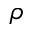Convert formula to latex. <formula><loc_0><loc_0><loc_500><loc_500>\rho</formula> 